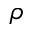Convert formula to latex. <formula><loc_0><loc_0><loc_500><loc_500>\rho</formula> 